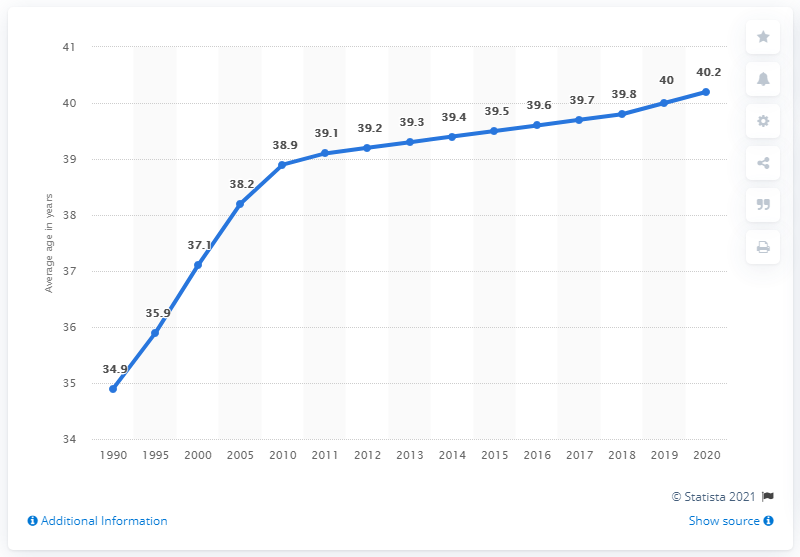What was the average age of the Russian population in 1990? In 1990, the average age of the Russian population was 34.9 years. This demographic metric offers insights into the age distribution at the time, reflecting a relatively young population base likely influenced by post-World War II birth rates. 